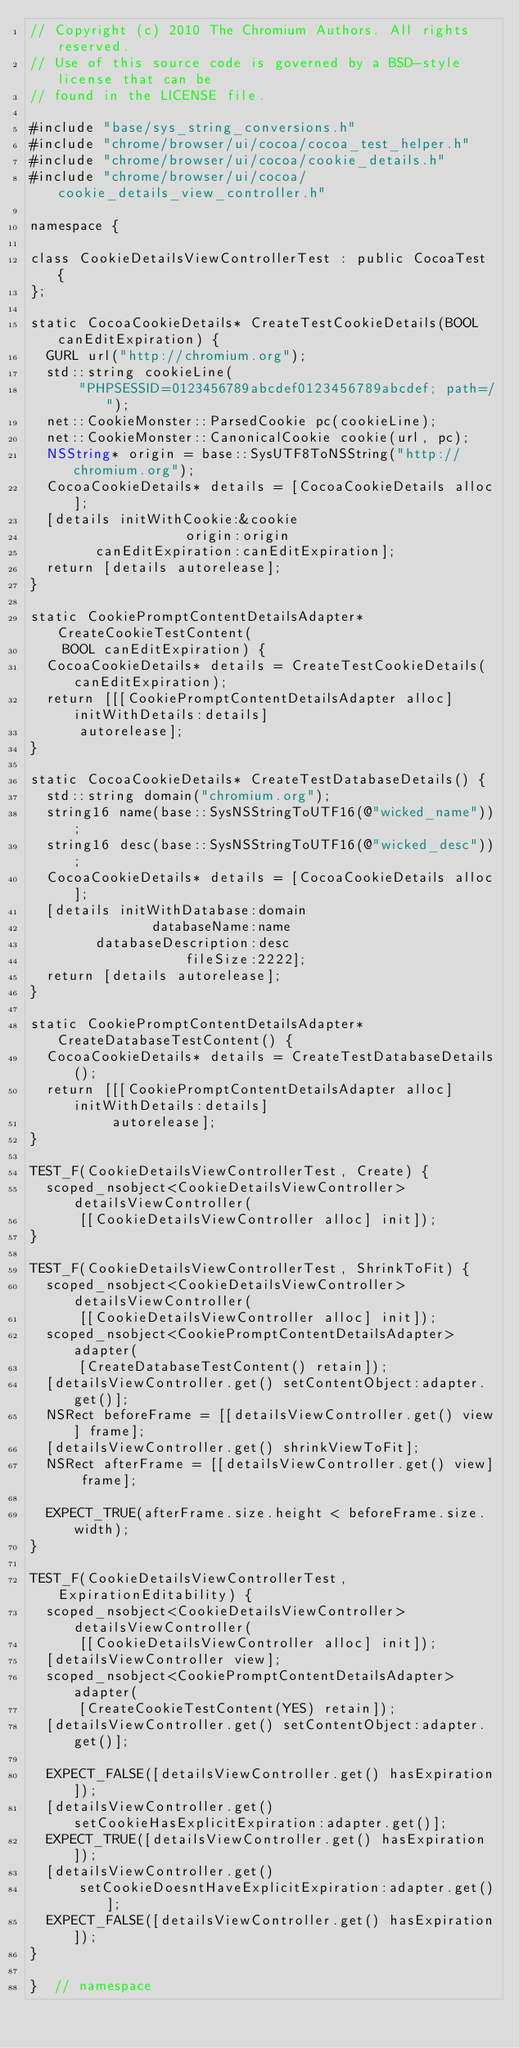Convert code to text. <code><loc_0><loc_0><loc_500><loc_500><_ObjectiveC_>// Copyright (c) 2010 The Chromium Authors. All rights reserved.
// Use of this source code is governed by a BSD-style license that can be
// found in the LICENSE file.

#include "base/sys_string_conversions.h"
#include "chrome/browser/ui/cocoa/cocoa_test_helper.h"
#include "chrome/browser/ui/cocoa/cookie_details.h"
#include "chrome/browser/ui/cocoa/cookie_details_view_controller.h"

namespace {

class CookieDetailsViewControllerTest : public CocoaTest {
};

static CocoaCookieDetails* CreateTestCookieDetails(BOOL canEditExpiration) {
  GURL url("http://chromium.org");
  std::string cookieLine(
      "PHPSESSID=0123456789abcdef0123456789abcdef; path=/");
  net::CookieMonster::ParsedCookie pc(cookieLine);
  net::CookieMonster::CanonicalCookie cookie(url, pc);
  NSString* origin = base::SysUTF8ToNSString("http://chromium.org");
  CocoaCookieDetails* details = [CocoaCookieDetails alloc];
  [details initWithCookie:&cookie
                   origin:origin
        canEditExpiration:canEditExpiration];
  return [details autorelease];
}

static CookiePromptContentDetailsAdapter* CreateCookieTestContent(
    BOOL canEditExpiration) {
  CocoaCookieDetails* details = CreateTestCookieDetails(canEditExpiration);
  return [[[CookiePromptContentDetailsAdapter alloc] initWithDetails:details]
      autorelease];
}

static CocoaCookieDetails* CreateTestDatabaseDetails() {
  std::string domain("chromium.org");
  string16 name(base::SysNSStringToUTF16(@"wicked_name"));
  string16 desc(base::SysNSStringToUTF16(@"wicked_desc"));
  CocoaCookieDetails* details = [CocoaCookieDetails alloc];
  [details initWithDatabase:domain
               databaseName:name
        databaseDescription:desc
                   fileSize:2222];
  return [details autorelease];
}

static CookiePromptContentDetailsAdapter* CreateDatabaseTestContent() {
  CocoaCookieDetails* details = CreateTestDatabaseDetails();
  return [[[CookiePromptContentDetailsAdapter alloc] initWithDetails:details]
          autorelease];
}

TEST_F(CookieDetailsViewControllerTest, Create) {
  scoped_nsobject<CookieDetailsViewController> detailsViewController(
      [[CookieDetailsViewController alloc] init]);
}

TEST_F(CookieDetailsViewControllerTest, ShrinkToFit) {
  scoped_nsobject<CookieDetailsViewController> detailsViewController(
      [[CookieDetailsViewController alloc] init]);
  scoped_nsobject<CookiePromptContentDetailsAdapter> adapter(
      [CreateDatabaseTestContent() retain]);
  [detailsViewController.get() setContentObject:adapter.get()];
  NSRect beforeFrame = [[detailsViewController.get() view] frame];
  [detailsViewController.get() shrinkViewToFit];
  NSRect afterFrame = [[detailsViewController.get() view] frame];

  EXPECT_TRUE(afterFrame.size.height < beforeFrame.size.width);
}

TEST_F(CookieDetailsViewControllerTest, ExpirationEditability) {
  scoped_nsobject<CookieDetailsViewController> detailsViewController(
      [[CookieDetailsViewController alloc] init]);
  [detailsViewController view];
  scoped_nsobject<CookiePromptContentDetailsAdapter> adapter(
      [CreateCookieTestContent(YES) retain]);
  [detailsViewController.get() setContentObject:adapter.get()];

  EXPECT_FALSE([detailsViewController.get() hasExpiration]);
  [detailsViewController.get() setCookieHasExplicitExpiration:adapter.get()];
  EXPECT_TRUE([detailsViewController.get() hasExpiration]);
  [detailsViewController.get()
      setCookieDoesntHaveExplicitExpiration:adapter.get()];
  EXPECT_FALSE([detailsViewController.get() hasExpiration]);
}

}  // namespace
</code> 